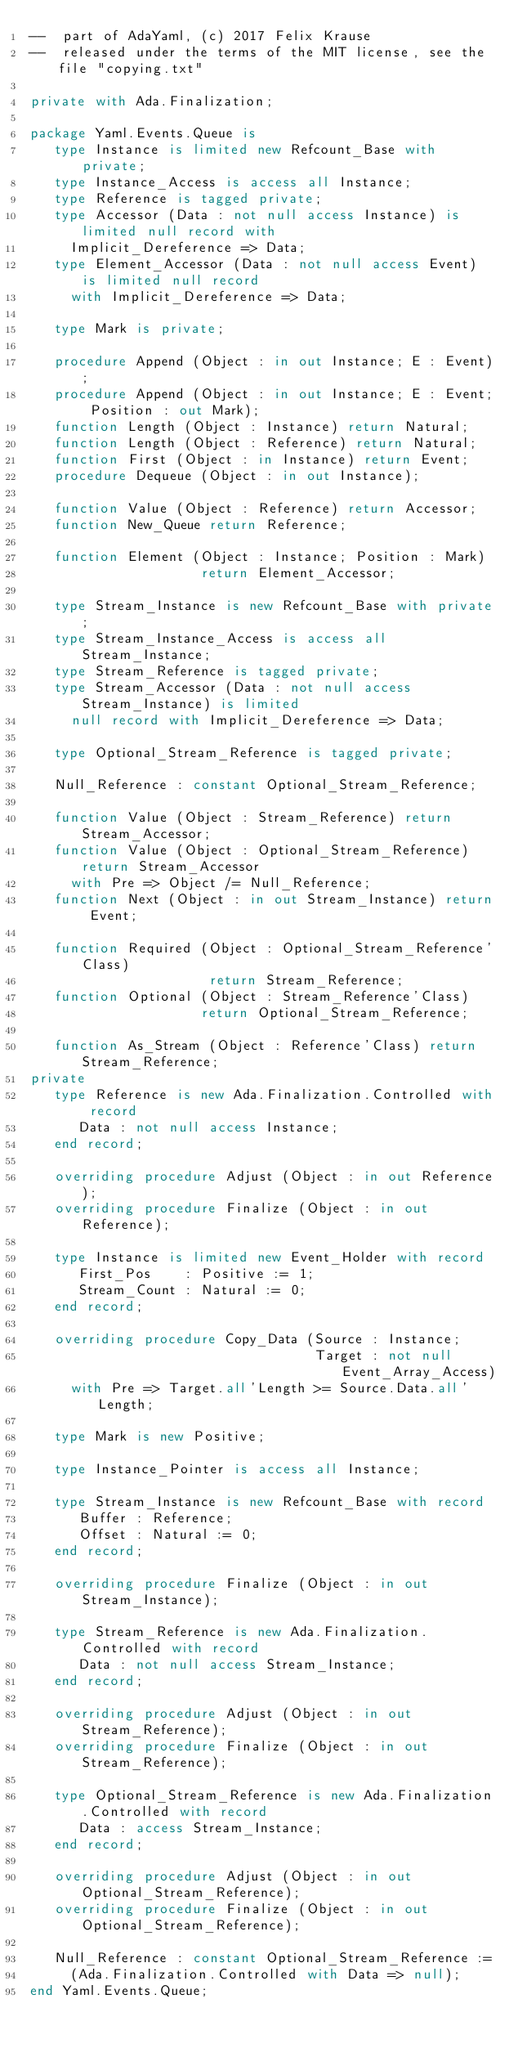<code> <loc_0><loc_0><loc_500><loc_500><_Ada_>--  part of AdaYaml, (c) 2017 Felix Krause
--  released under the terms of the MIT license, see the file "copying.txt"

private with Ada.Finalization;

package Yaml.Events.Queue is
   type Instance is limited new Refcount_Base with private;
   type Instance_Access is access all Instance;
   type Reference is tagged private;
   type Accessor (Data : not null access Instance) is limited null record with
     Implicit_Dereference => Data;
   type Element_Accessor (Data : not null access Event) is limited null record
     with Implicit_Dereference => Data;

   type Mark is private;

   procedure Append (Object : in out Instance; E : Event);
   procedure Append (Object : in out Instance; E : Event; Position : out Mark);
   function Length (Object : Instance) return Natural;
   function Length (Object : Reference) return Natural;
   function First (Object : in Instance) return Event;
   procedure Dequeue (Object : in out Instance);

   function Value (Object : Reference) return Accessor;
   function New_Queue return Reference;

   function Element (Object : Instance; Position : Mark)
                     return Element_Accessor;

   type Stream_Instance is new Refcount_Base with private;
   type Stream_Instance_Access is access all Stream_Instance;
   type Stream_Reference is tagged private;
   type Stream_Accessor (Data : not null access Stream_Instance) is limited
     null record with Implicit_Dereference => Data;

   type Optional_Stream_Reference is tagged private;

   Null_Reference : constant Optional_Stream_Reference;

   function Value (Object : Stream_Reference) return Stream_Accessor;
   function Value (Object : Optional_Stream_Reference) return Stream_Accessor
     with Pre => Object /= Null_Reference;
   function Next (Object : in out Stream_Instance) return Event;

   function Required (Object : Optional_Stream_Reference'Class)
                      return Stream_Reference;
   function Optional (Object : Stream_Reference'Class)
                     return Optional_Stream_Reference;

   function As_Stream (Object : Reference'Class) return Stream_Reference;
private
   type Reference is new Ada.Finalization.Controlled with record
      Data : not null access Instance;
   end record;

   overriding procedure Adjust (Object : in out Reference);
   overriding procedure Finalize (Object : in out Reference);

   type Instance is limited new Event_Holder with record
      First_Pos    : Positive := 1;
      Stream_Count : Natural := 0;
   end record;

   overriding procedure Copy_Data (Source : Instance;
                                   Target : not null Event_Array_Access)
     with Pre => Target.all'Length >= Source.Data.all'Length;

   type Mark is new Positive;

   type Instance_Pointer is access all Instance;

   type Stream_Instance is new Refcount_Base with record
      Buffer : Reference;
      Offset : Natural := 0;
   end record;

   overriding procedure Finalize (Object : in out Stream_Instance);

   type Stream_Reference is new Ada.Finalization.Controlled with record
      Data : not null access Stream_Instance;
   end record;

   overriding procedure Adjust (Object : in out Stream_Reference);
   overriding procedure Finalize (Object : in out Stream_Reference);

   type Optional_Stream_Reference is new Ada.Finalization.Controlled with record
      Data : access Stream_Instance;
   end record;

   overriding procedure Adjust (Object : in out Optional_Stream_Reference);
   overriding procedure Finalize (Object : in out Optional_Stream_Reference);

   Null_Reference : constant Optional_Stream_Reference :=
     (Ada.Finalization.Controlled with Data => null);
end Yaml.Events.Queue;
</code> 